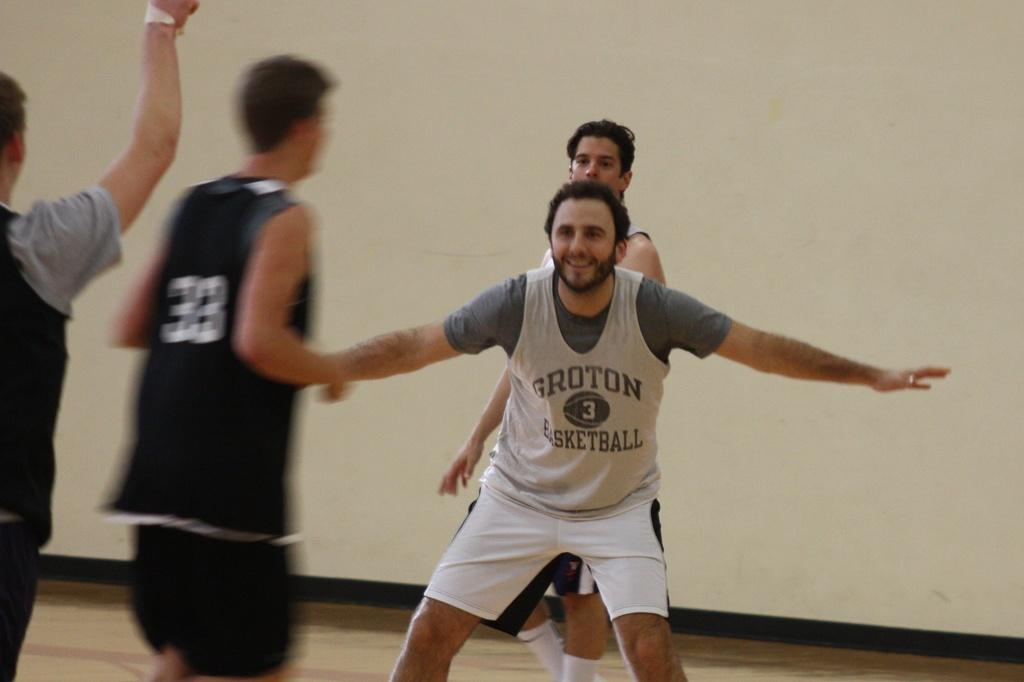<image>
Write a terse but informative summary of the picture. a man with the number 3 on his jersey playing basketball 